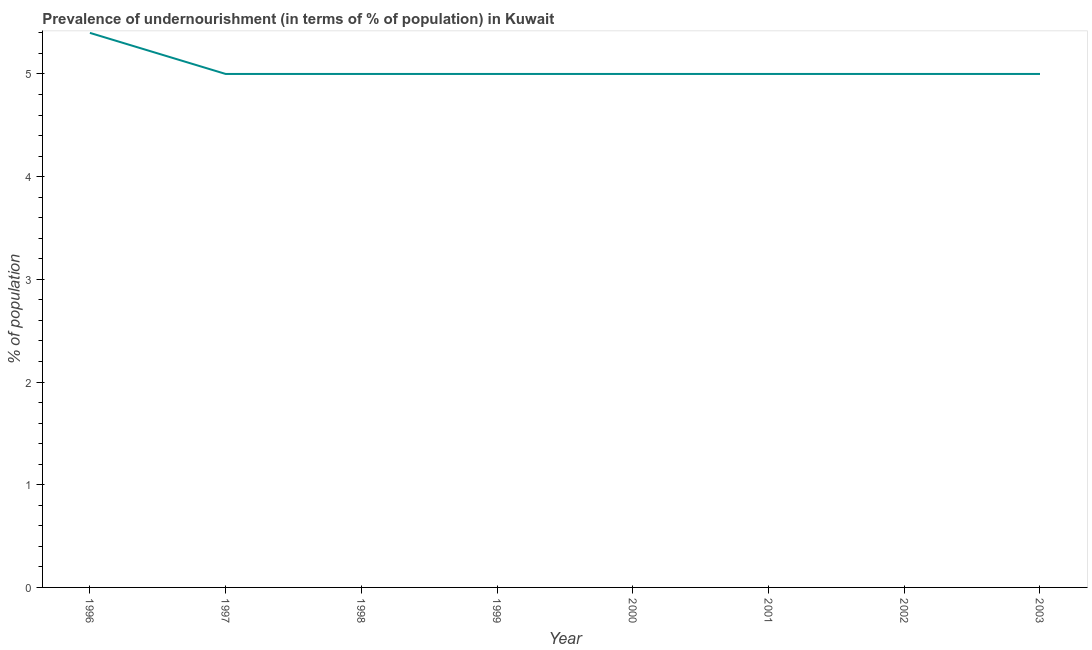What is the percentage of undernourished population in 2003?
Make the answer very short. 5. Across all years, what is the maximum percentage of undernourished population?
Provide a succinct answer. 5.4. In which year was the percentage of undernourished population maximum?
Ensure brevity in your answer.  1996. What is the sum of the percentage of undernourished population?
Ensure brevity in your answer.  40.4. What is the average percentage of undernourished population per year?
Offer a very short reply. 5.05. Do a majority of the years between 1998 and 1999 (inclusive) have percentage of undernourished population greater than 4.2 %?
Keep it short and to the point. Yes. Is the percentage of undernourished population in 1996 less than that in 2001?
Your answer should be compact. No. Is the difference between the percentage of undernourished population in 1997 and 2003 greater than the difference between any two years?
Give a very brief answer. No. What is the difference between the highest and the second highest percentage of undernourished population?
Your answer should be very brief. 0.4. What is the difference between the highest and the lowest percentage of undernourished population?
Your answer should be compact. 0.4. How many lines are there?
Give a very brief answer. 1. What is the difference between two consecutive major ticks on the Y-axis?
Provide a short and direct response. 1. What is the title of the graph?
Your answer should be compact. Prevalence of undernourishment (in terms of % of population) in Kuwait. What is the label or title of the Y-axis?
Offer a terse response. % of population. What is the % of population of 1997?
Your answer should be very brief. 5. What is the % of population of 1999?
Give a very brief answer. 5. What is the % of population of 2001?
Make the answer very short. 5. What is the % of population of 2002?
Make the answer very short. 5. What is the % of population in 2003?
Your answer should be very brief. 5. What is the difference between the % of population in 1996 and 1997?
Make the answer very short. 0.4. What is the difference between the % of population in 1996 and 1999?
Your answer should be very brief. 0.4. What is the difference between the % of population in 1996 and 2003?
Offer a terse response. 0.4. What is the difference between the % of population in 1997 and 1999?
Keep it short and to the point. 0. What is the difference between the % of population in 1997 and 2000?
Make the answer very short. 0. What is the difference between the % of population in 1997 and 2003?
Provide a succinct answer. 0. What is the difference between the % of population in 1998 and 2000?
Keep it short and to the point. 0. What is the difference between the % of population in 1998 and 2001?
Keep it short and to the point. 0. What is the difference between the % of population in 1998 and 2002?
Offer a terse response. 0. What is the difference between the % of population in 1999 and 2000?
Keep it short and to the point. 0. What is the difference between the % of population in 1999 and 2001?
Provide a short and direct response. 0. What is the difference between the % of population in 1999 and 2002?
Your answer should be very brief. 0. What is the difference between the % of population in 2000 and 2001?
Ensure brevity in your answer.  0. What is the difference between the % of population in 2000 and 2002?
Your answer should be very brief. 0. What is the difference between the % of population in 2000 and 2003?
Ensure brevity in your answer.  0. What is the difference between the % of population in 2001 and 2002?
Give a very brief answer. 0. What is the difference between the % of population in 2001 and 2003?
Ensure brevity in your answer.  0. What is the difference between the % of population in 2002 and 2003?
Give a very brief answer. 0. What is the ratio of the % of population in 1996 to that in 1997?
Keep it short and to the point. 1.08. What is the ratio of the % of population in 1996 to that in 1999?
Your response must be concise. 1.08. What is the ratio of the % of population in 1996 to that in 2001?
Offer a very short reply. 1.08. What is the ratio of the % of population in 1996 to that in 2002?
Your answer should be compact. 1.08. What is the ratio of the % of population in 1997 to that in 1998?
Your answer should be very brief. 1. What is the ratio of the % of population in 1998 to that in 2001?
Give a very brief answer. 1. What is the ratio of the % of population in 1998 to that in 2002?
Keep it short and to the point. 1. What is the ratio of the % of population in 1999 to that in 2000?
Your answer should be compact. 1. What is the ratio of the % of population in 1999 to that in 2002?
Offer a very short reply. 1. What is the ratio of the % of population in 2001 to that in 2003?
Ensure brevity in your answer.  1. What is the ratio of the % of population in 2002 to that in 2003?
Offer a very short reply. 1. 